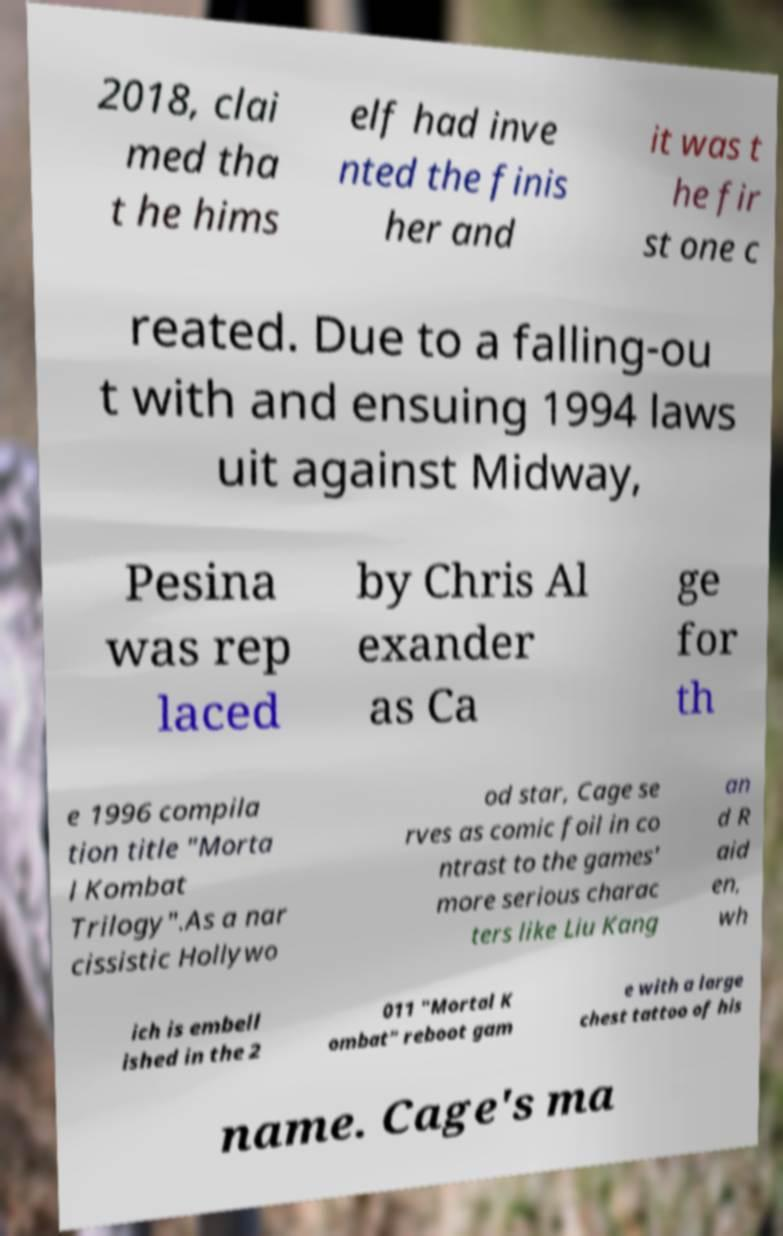I need the written content from this picture converted into text. Can you do that? 2018, clai med tha t he hims elf had inve nted the finis her and it was t he fir st one c reated. Due to a falling-ou t with and ensuing 1994 laws uit against Midway, Pesina was rep laced by Chris Al exander as Ca ge for th e 1996 compila tion title "Morta l Kombat Trilogy".As a nar cissistic Hollywo od star, Cage se rves as comic foil in co ntrast to the games' more serious charac ters like Liu Kang an d R aid en, wh ich is embell ished in the 2 011 "Mortal K ombat" reboot gam e with a large chest tattoo of his name. Cage's ma 